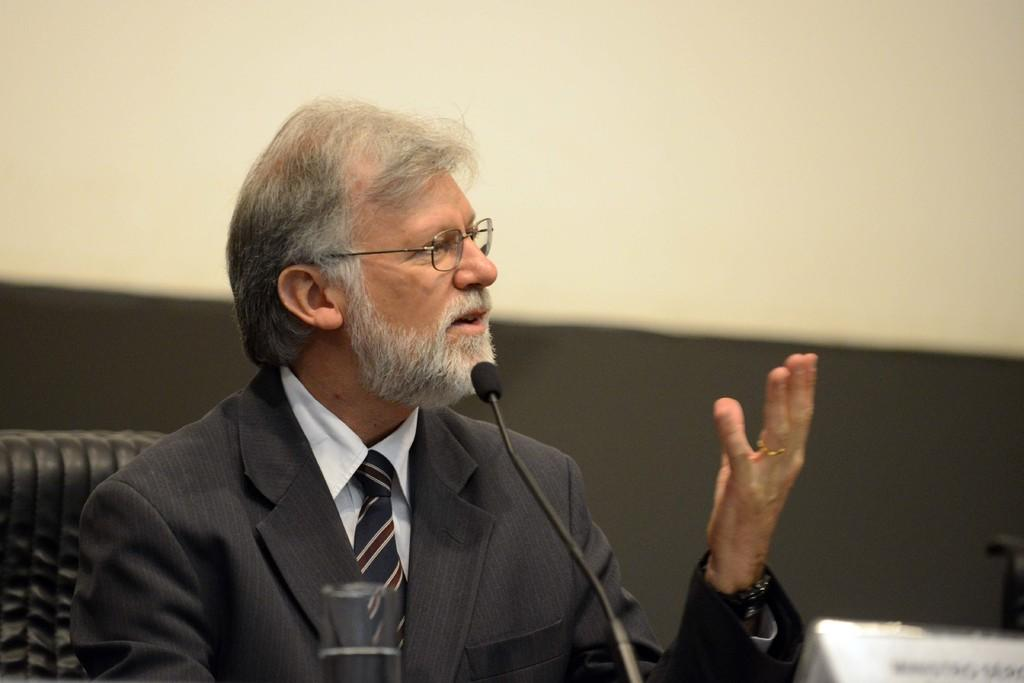What is the man in the image doing? The man is sitting and speaking in the image. What type of clothing is the man wearing? The man is wearing a suit, a shirt, and a tie. What accessory is the man wearing on his face? The man is wearing spectacles. What object is present for the man to speak into? There is a microphone (mike) in the image. What object is present for the man's name to be displayed? There is a name board in the image. What can be seen in the background of the image? There is a wall in the image. What type of shade can be seen on the trees in the image? There are no trees present in the image, so there is no shade to be seen. 